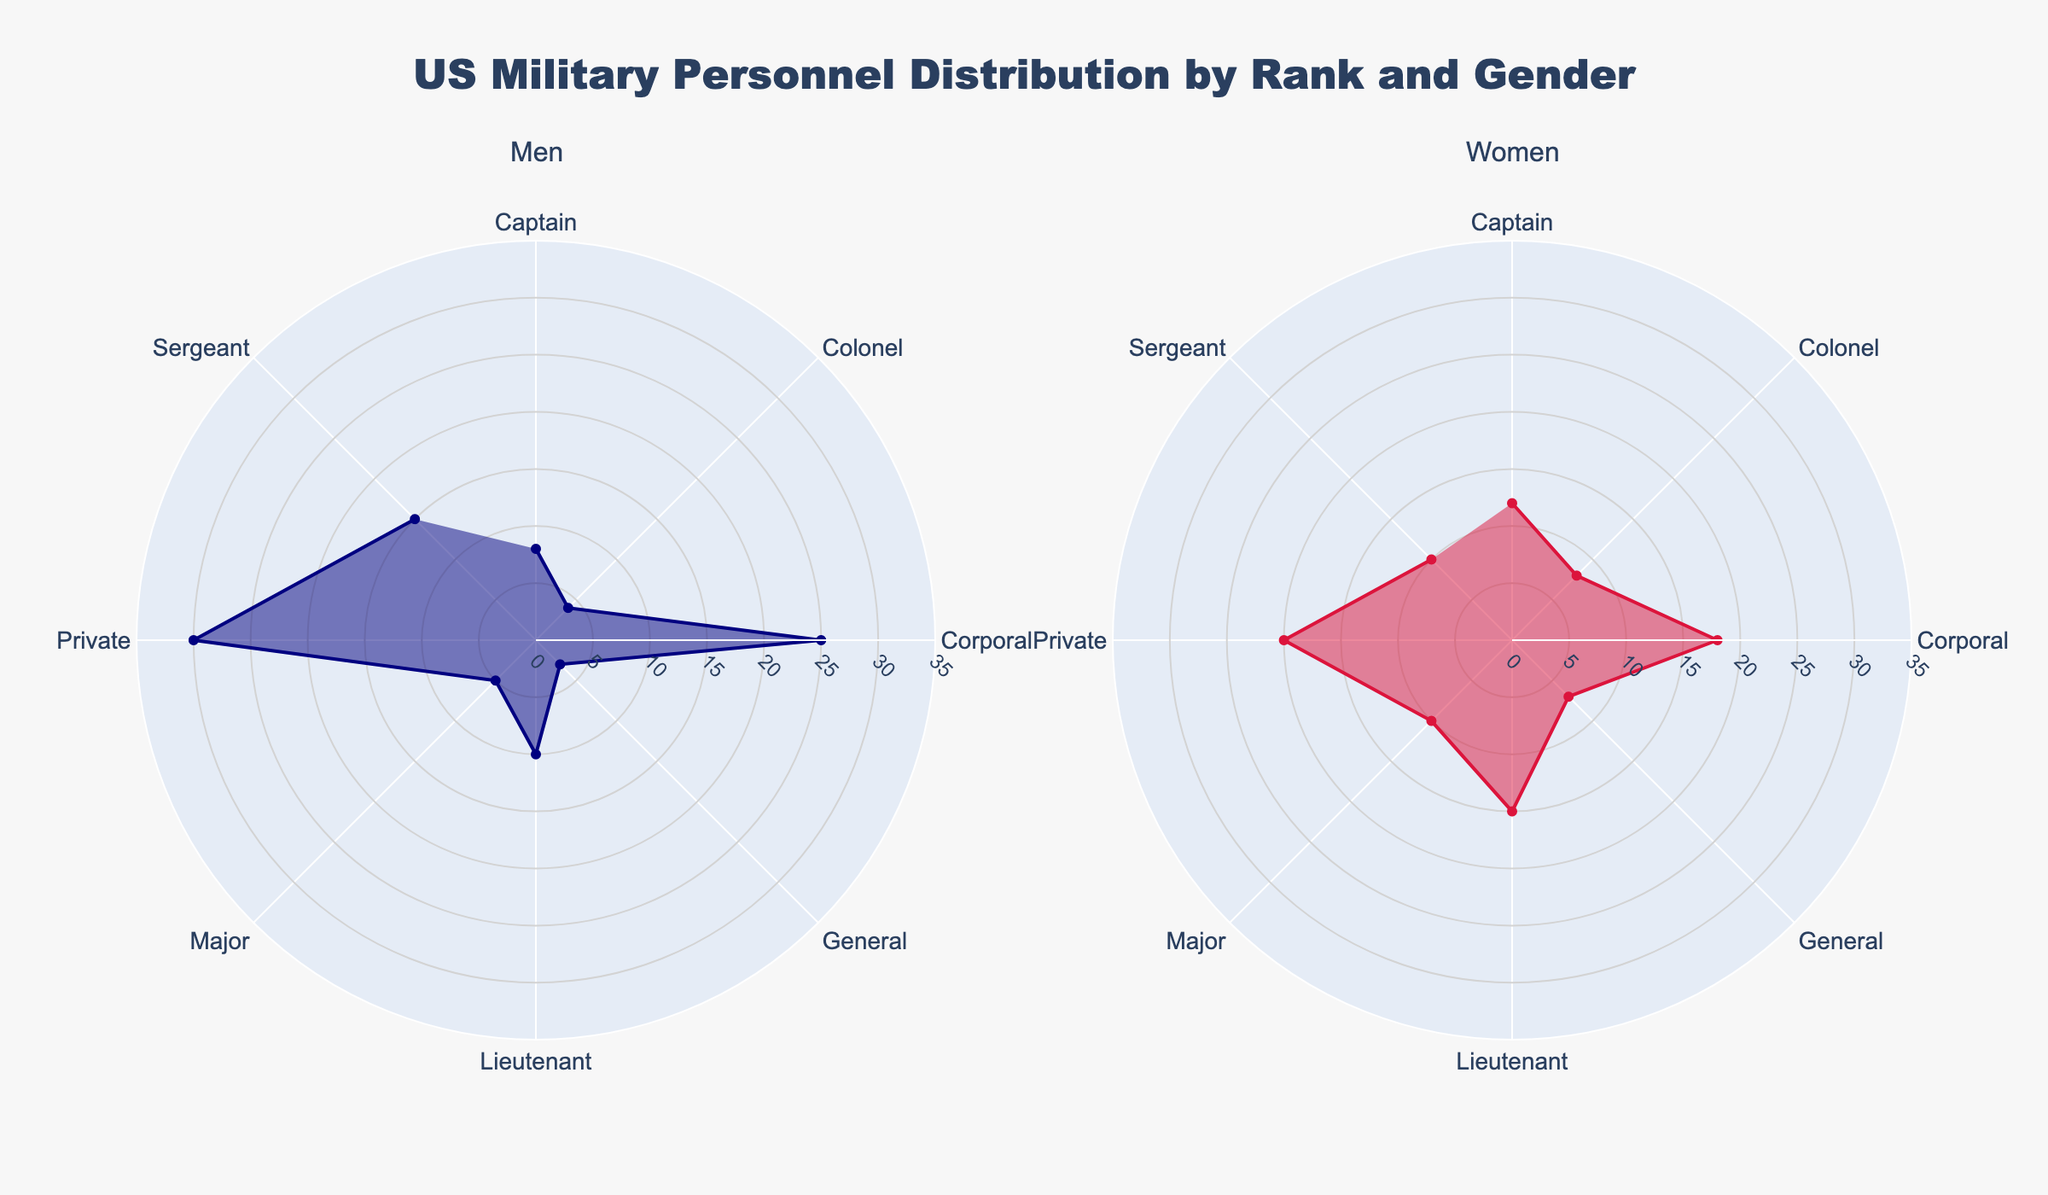What is the title of the figure? The title is prominently displayed at the top of the radar chart and reads, "US Military Personnel Distribution by Rank and Gender"
Answer: US Military Personnel Distribution by Rank and Gender Which rank has the highest percentage of men? The radar chart shows the percentage distribution for each rank. The rank with the longest radial line on the "Men" subplot is "Private," which has a percentage of 30%.
Answer: Private What is the percentage of women in the "General" rank? On the radar chart subplot for women, find the radial line corresponding to "General." The percentage value is marked and is 7%.
Answer: 7% What are the percentages of men and women for the "Lieutenant" rank? In the men's subplot, "Lieutenant" has a percentage of 10%, and in the women's subplot, "Lieutenant" has a percentage of 15%.
Answer: Men: 10%, Women: 15% Comparing the "Sergeant" rank, which gender has a higher percentage, and by how much? In the radar charts, the "Sergeant" rank shows a percentage of 15% for men and 10% for women. The difference is calculated by subtracting the lower percentage from the higher: 15% - 10% = 5%. Therefore, men have a higher percentage by 5%.
Answer: Men by 5% What is the total percentage of personnel at the "Private," "Corporal," and "Sergeant" ranks for men? Sum the percentages of men at the specified ranks: Private (30%) + Corporal (25%) + Sergeant (15%) = 70%.
Answer: 70% For women, how many ranks have a percentage greater than 10%? By examining the radial lines on the women's subplot, the ranks with percentages greater than 10% are "Lieutenant," "Captain," "Major," and "Colonel." There are 4 such ranks.
Answer: 4 Which rank has the smallest percentage for men, and what is that percentage? In the men's subplot, the rank with the shortest radial line is "General," with a percentage of 3%.
Answer: General, 3% What is the average percentage of women across all ranks? Sum all the percentages for women and divide by the number of ranks. Calculation: (20 + 18 + 10 + 15 + 12 + 10 + 8 + 7) / 8 = 100 / 8 = 12.5%.
Answer: 12.5% Do both men and women occupy all ranks shown in the radar chart? By examining both subplots, it is clear that all ranks from "Private" to "General" are occupied by both men and women, as each rank has corresponding percentage values for both genders.
Answer: Yes 